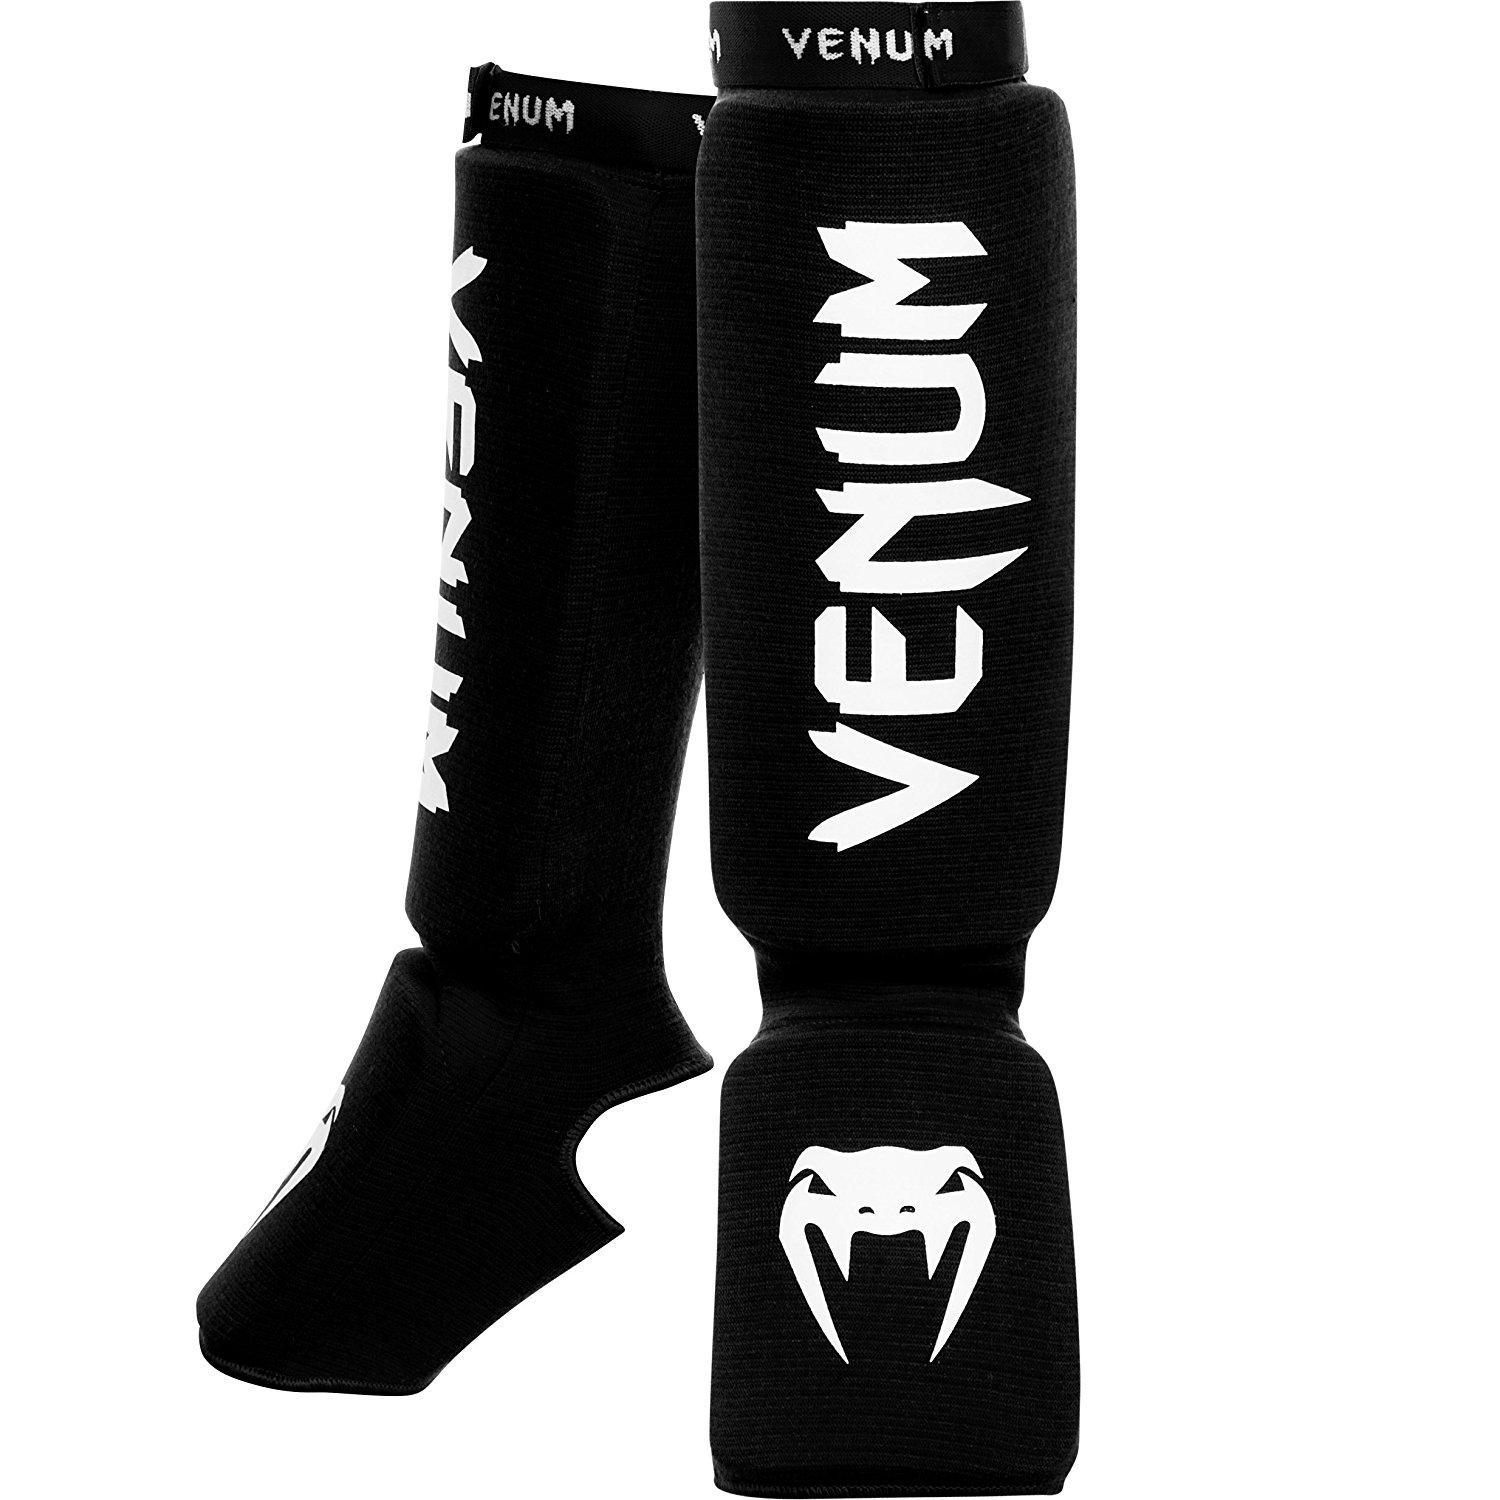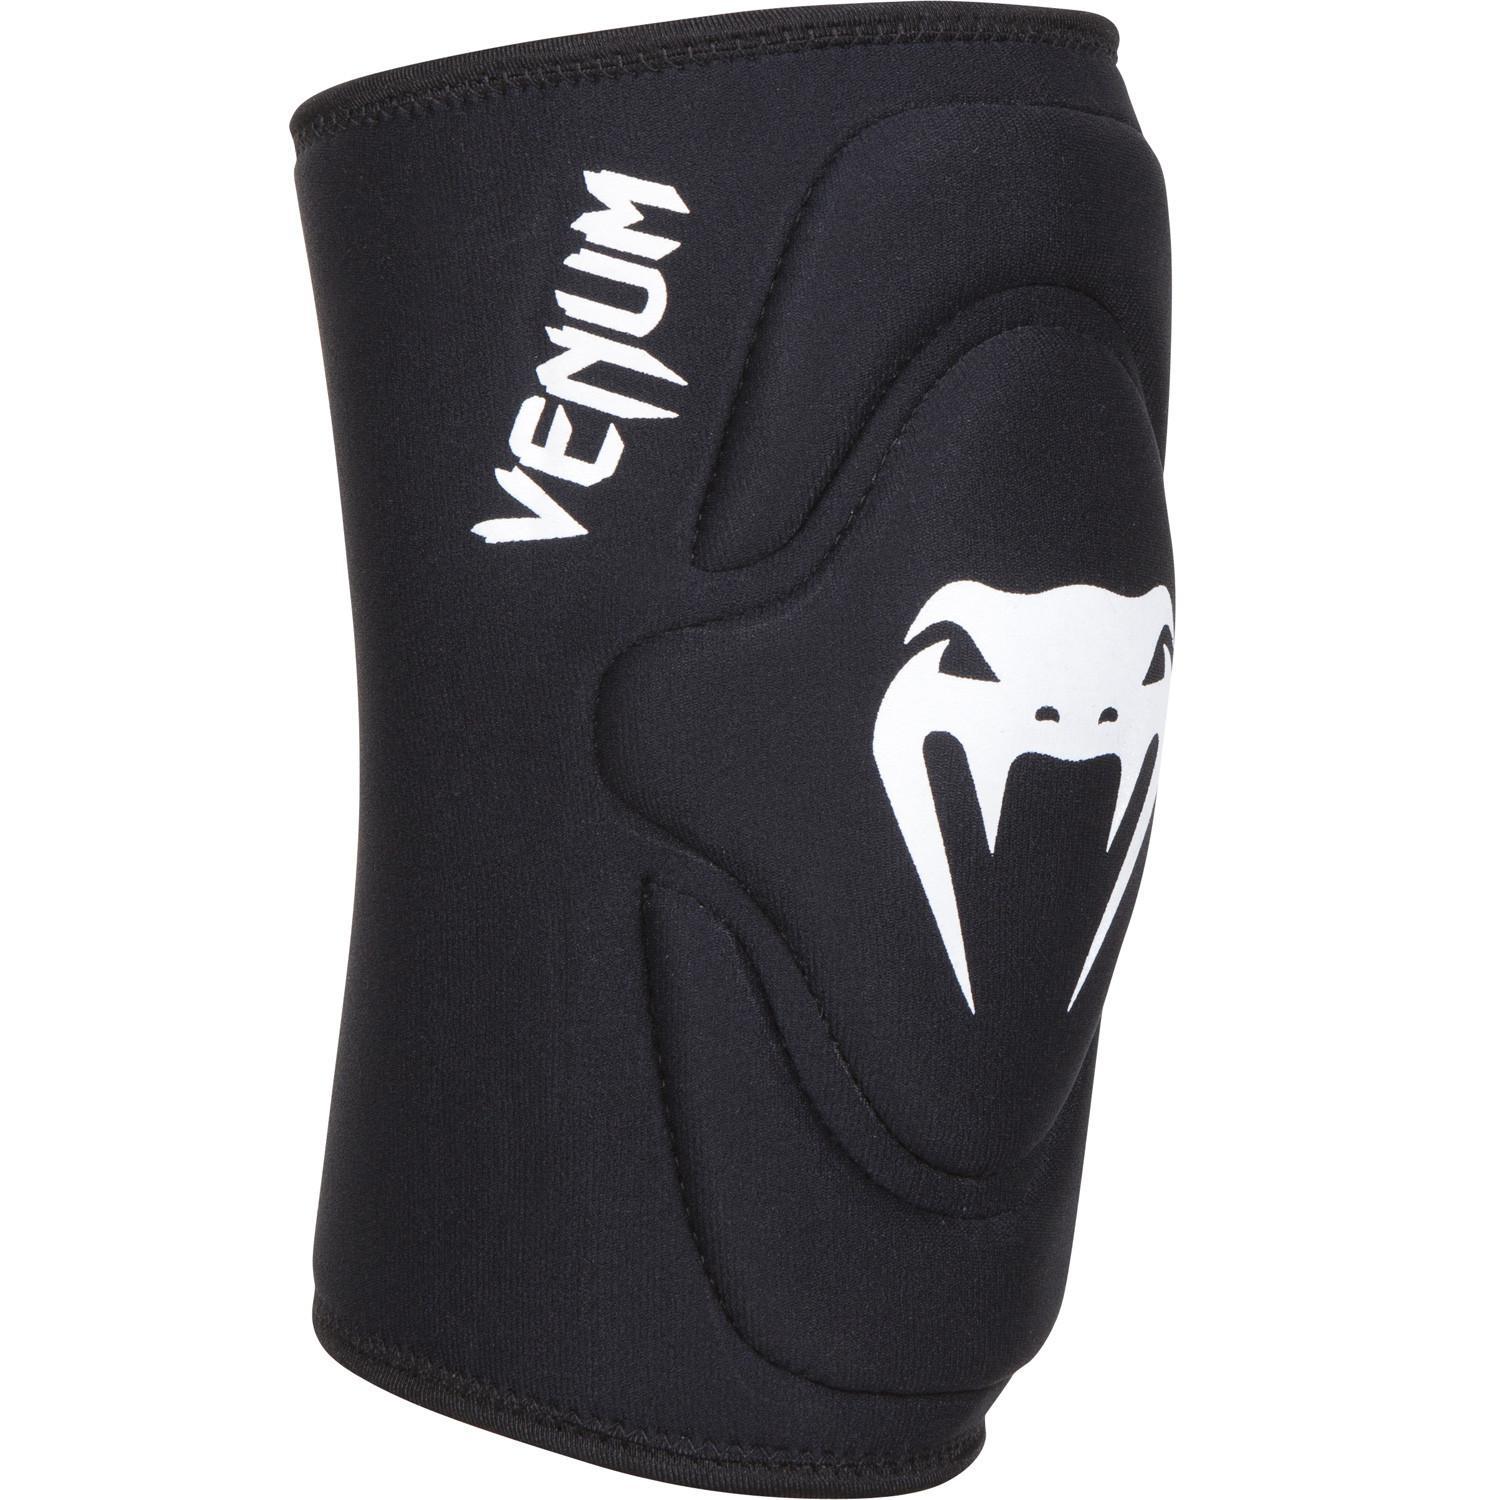The first image is the image on the left, the second image is the image on the right. Assess this claim about the two images: "A total of two knee pads without a knee opening are shown.". Correct or not? Answer yes or no. No. 